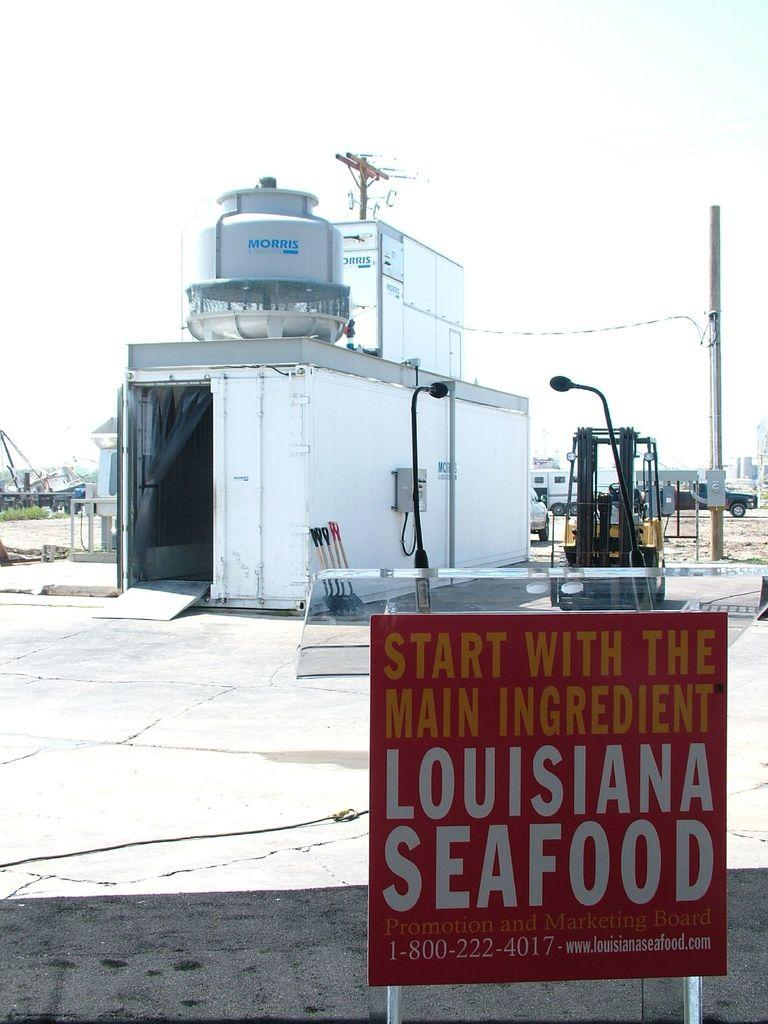<image>
Present a compact description of the photo's key features. A white shipping container is open and a tank on top of it says Morris. 